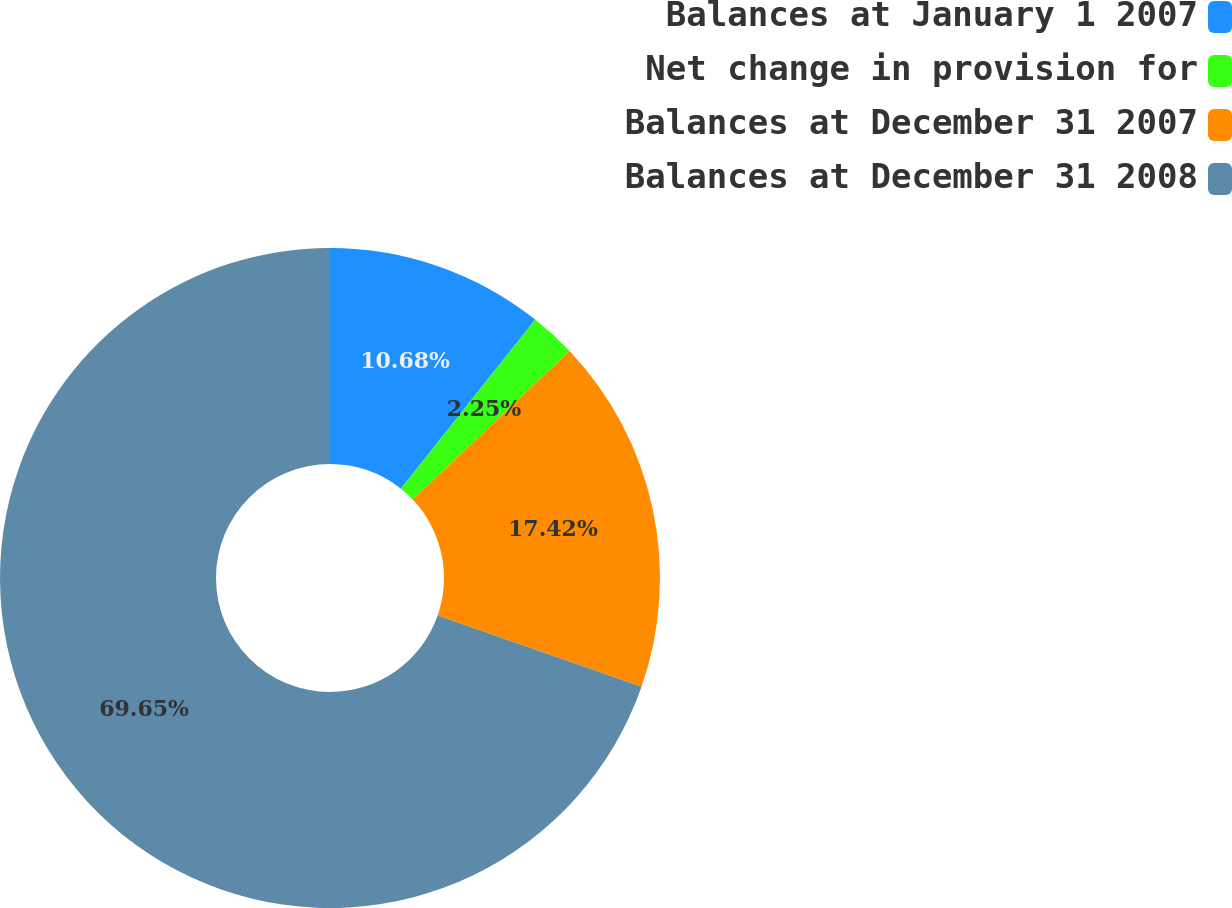Convert chart. <chart><loc_0><loc_0><loc_500><loc_500><pie_chart><fcel>Balances at January 1 2007<fcel>Net change in provision for<fcel>Balances at December 31 2007<fcel>Balances at December 31 2008<nl><fcel>10.68%<fcel>2.25%<fcel>17.42%<fcel>69.65%<nl></chart> 